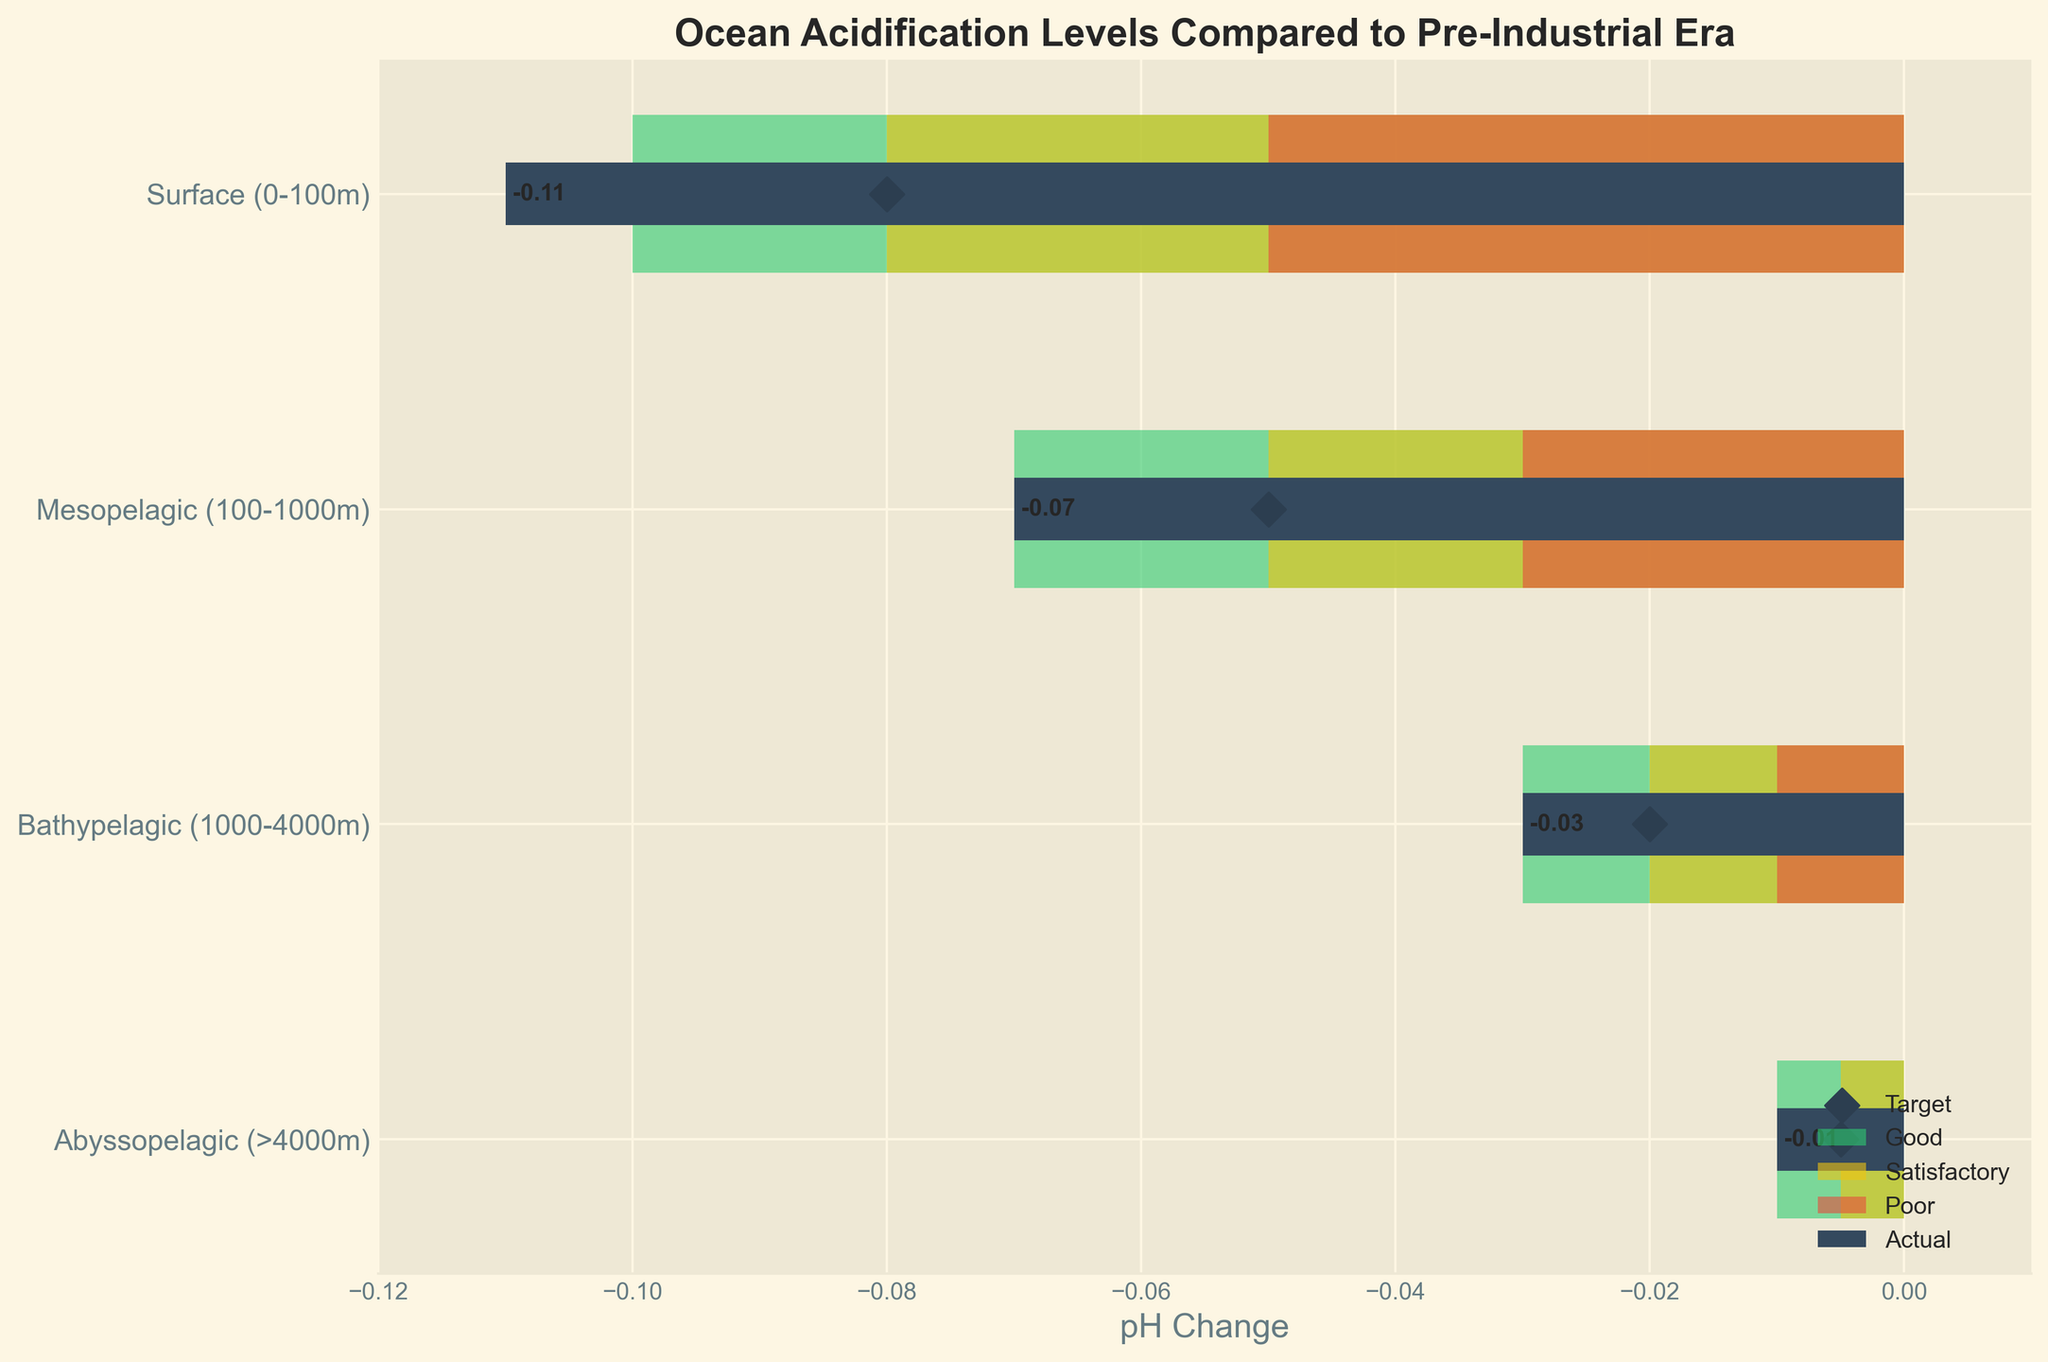What is the title of the figure? The title of the figure is given at the top of the chart and summarizes the main idea of the visual.
Answer: Ocean Acidification Levels Compared to Pre-Industrial Era How many depth categories are shown in the figure? The figure shows different ocean depth levels, which are labeled on the y-axis. Count these labels to determine the number of categories.
Answer: 4 What is the actual pH change in the Surface category? Look at the 'Actual' bar for the 'Surface (0-100m)' category to find the pH change value. It is also annotated on the bar.
Answer: -0.11 What is the target pH change at Bathypelagic depth? Locate the 'Bathypelagic (1000-4000m)' category and look at the diamond marker which represents the target pH change.
Answer: -0.02 In which category does the actual pH change fall into the ‘Poor’ zone? Compare the ‘actual’ values against the value ranges of Poor zones. Look for where the actual value fits within the Poor range for each category.
Answer: Surface (0-100m) What is the average actual pH change across all depth categories? Sum the actual pH changes for all categories and divide by the number of categories. Calculation: (-0.11 + -0.07 + -0.03 + -0.01) / 4 = -0.055
Answer: -0.055 Which depth category's actual pH change deviates most from its target? Identify the category with the largest absolute difference between actual and target values. Calculation of differences: Surface: 0.03, Mesopelagic: 0.02, Bathypelagic: 0.01, Abyssopelagic: 0.005.
Answer: Surface (0-100m) Which category is the nearest to reaching a satisfactory pH change? Compare the actual pH change of each category with the threshold value for satisfactory performance. Determine the smallest distance to reaching the satisfactory mark.
Answer: Bathypelagic (1000-4000m) 